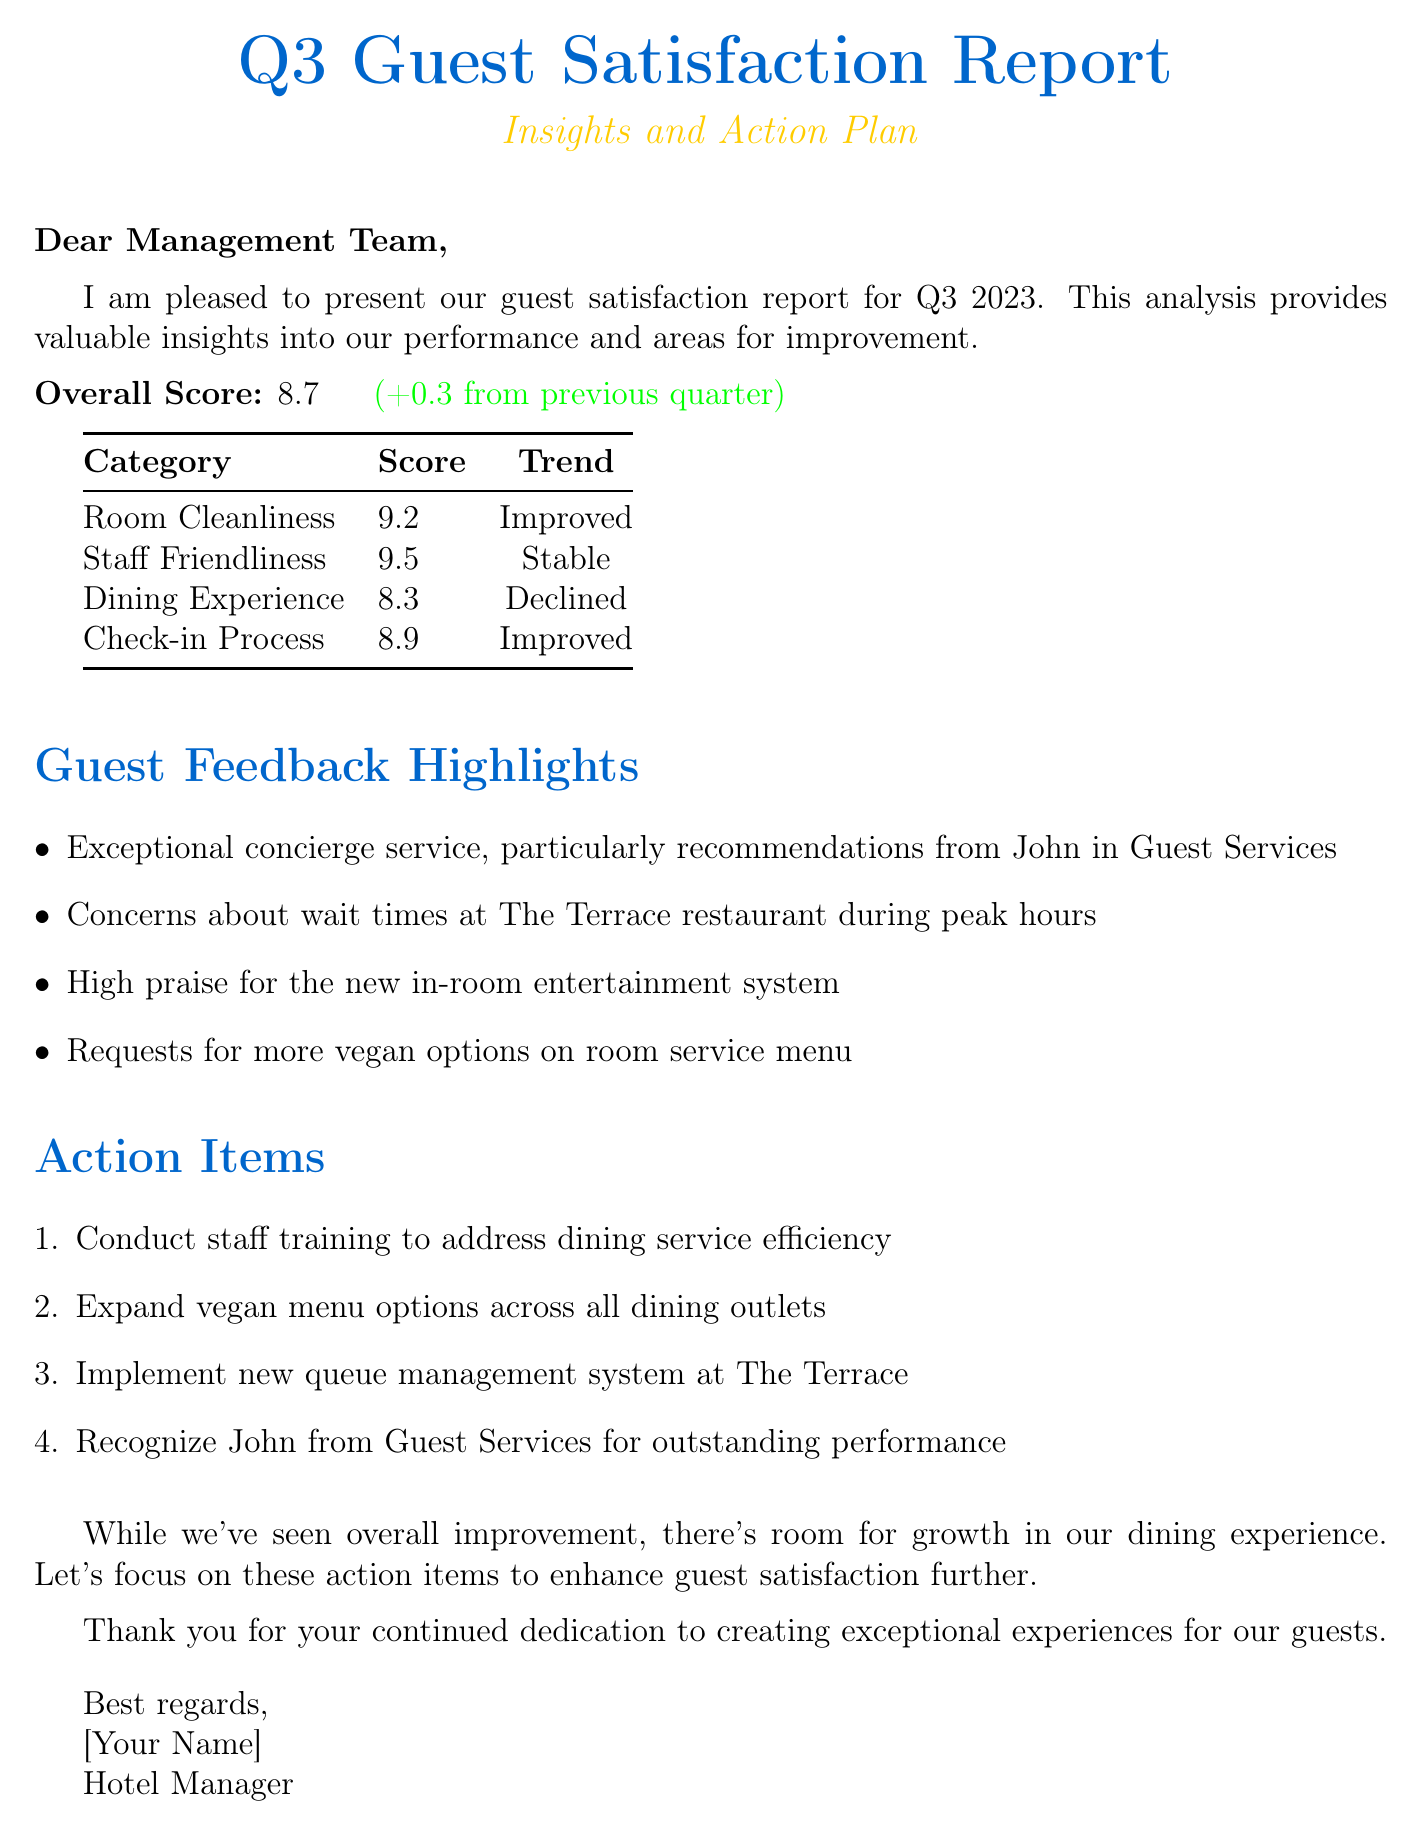what is the overall guest satisfaction score for Q3 2023? The overall guest satisfaction score is mentioned clearly at the beginning of the report.
Answer: 8.7 what was the previous overall guest satisfaction score? The previous score is provided alongside the current score to show improvement.
Answer: 8.4 which category had the highest score? The report lists the scores for each category, allowing us to identify the highest one.
Answer: Staff Friendliness what issue was raised regarding The Terrace restaurant? The feedback highlights specific concerns raised by guests, particularly regarding dining services.
Answer: Wait times how many action items are suggested to improve guest satisfaction? The action items section enumerates steps to address issues raised in feedback.
Answer: 4 which staff member was recognized for outstanding performance? The report includes accolades for exceptional service provided by certain staff members.
Answer: John what trend did Room Cleanliness experience this quarter? The trends for each category are included to give insight into performance changes.
Answer: Improved what score did the Dining Experience category receive? The document specifies numerical scores for each category, including the dining experience.
Answer: 8.3 